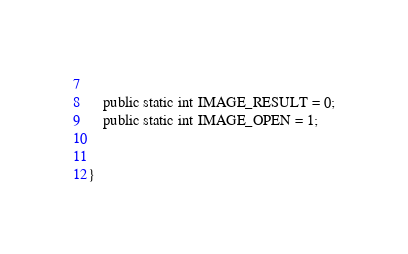<code> <loc_0><loc_0><loc_500><loc_500><_Java_>	
	public static int IMAGE_RESULT = 0;
	public static int IMAGE_OPEN = 1;
	

}
</code> 